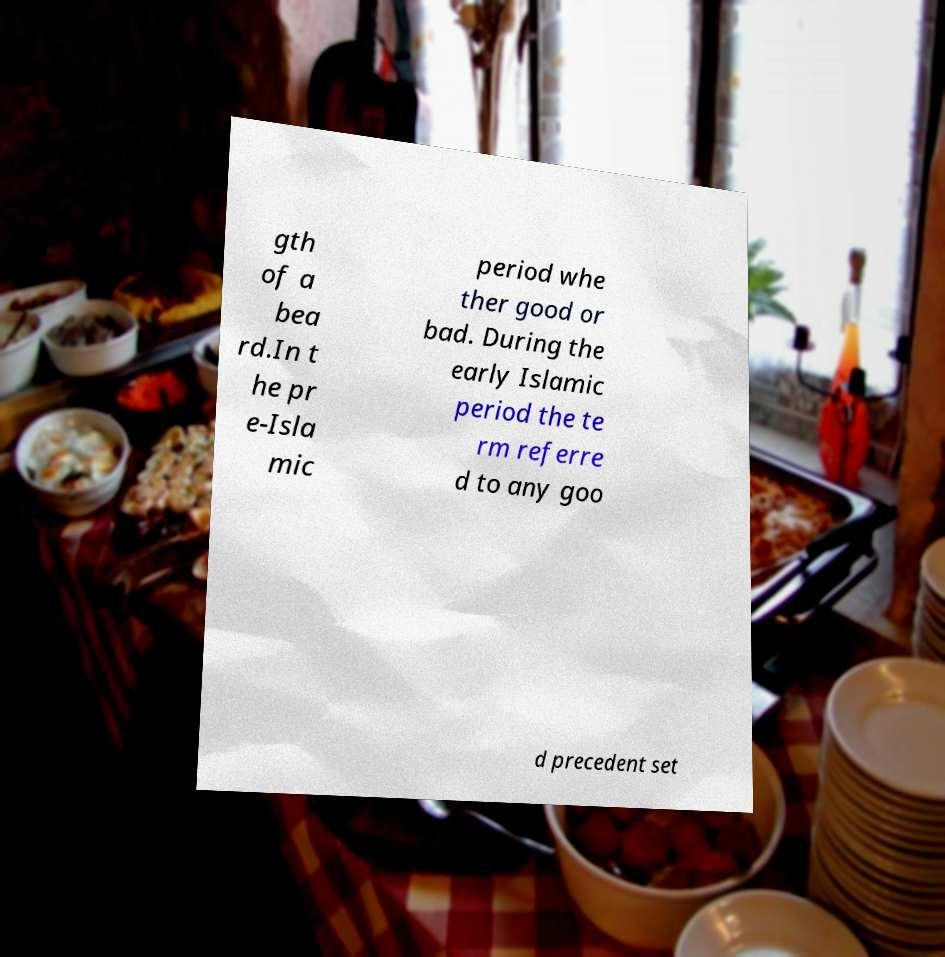Please read and relay the text visible in this image. What does it say? gth of a bea rd.In t he pr e-Isla mic period whe ther good or bad. During the early Islamic period the te rm referre d to any goo d precedent set 